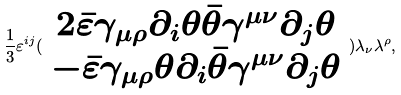<formula> <loc_0><loc_0><loc_500><loc_500>\frac { 1 } { 3 } \varepsilon ^ { i j } ( \begin{array} { c } 2 \bar { \varepsilon } \gamma _ { \mu \rho } \partial _ { i } \theta \bar { \theta } \gamma ^ { \mu \nu } \partial _ { j } \theta \\ - \bar { \varepsilon } \gamma _ { \mu \rho } \theta \partial _ { i } \bar { \theta } \gamma ^ { \mu \nu } \partial _ { j } \theta \end{array} ) \lambda _ { \nu } \lambda ^ { \rho } ,</formula> 